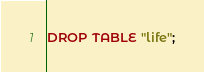Convert code to text. <code><loc_0><loc_0><loc_500><loc_500><_SQL_>DROP TABLE "life";</code> 